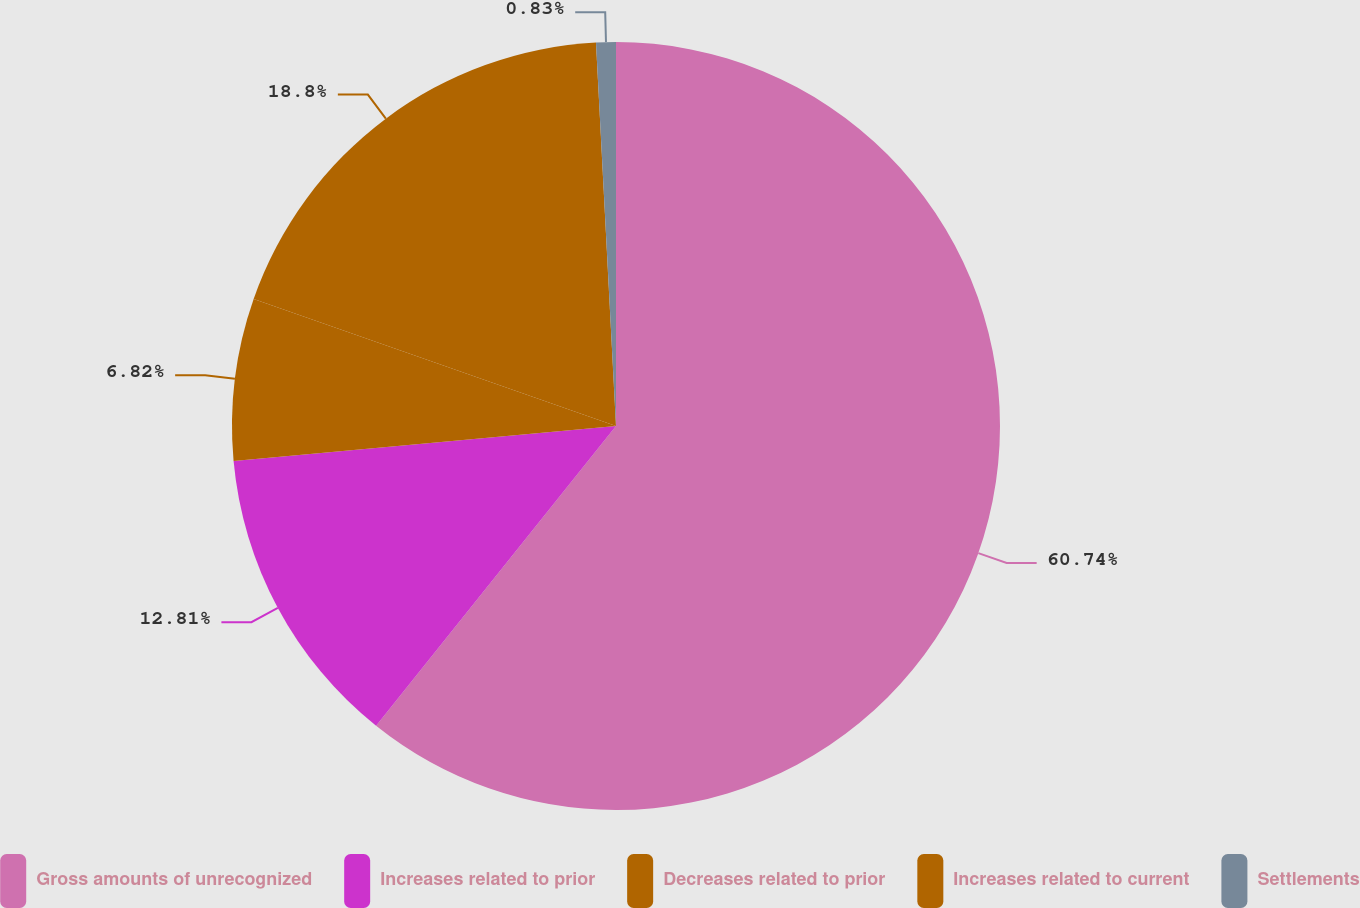Convert chart to OTSL. <chart><loc_0><loc_0><loc_500><loc_500><pie_chart><fcel>Gross amounts of unrecognized<fcel>Increases related to prior<fcel>Decreases related to prior<fcel>Increases related to current<fcel>Settlements<nl><fcel>60.74%<fcel>12.81%<fcel>6.82%<fcel>18.8%<fcel>0.83%<nl></chart> 